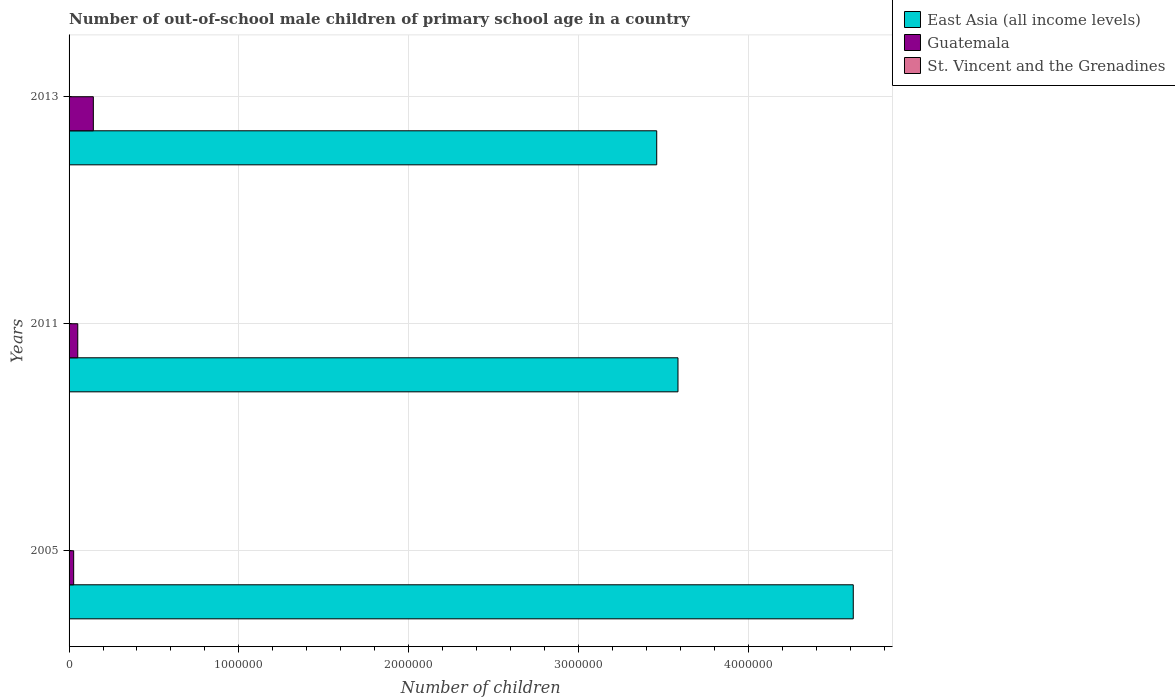How many different coloured bars are there?
Your answer should be compact. 3. Are the number of bars per tick equal to the number of legend labels?
Give a very brief answer. Yes. What is the number of out-of-school male children in East Asia (all income levels) in 2013?
Keep it short and to the point. 3.46e+06. Across all years, what is the maximum number of out-of-school male children in East Asia (all income levels)?
Give a very brief answer. 4.62e+06. Across all years, what is the minimum number of out-of-school male children in Guatemala?
Provide a succinct answer. 2.71e+04. What is the total number of out-of-school male children in East Asia (all income levels) in the graph?
Your response must be concise. 1.17e+07. What is the difference between the number of out-of-school male children in St. Vincent and the Grenadines in 2005 and that in 2011?
Make the answer very short. -191. What is the difference between the number of out-of-school male children in East Asia (all income levels) in 2005 and the number of out-of-school male children in St. Vincent and the Grenadines in 2011?
Keep it short and to the point. 4.62e+06. What is the average number of out-of-school male children in East Asia (all income levels) per year?
Ensure brevity in your answer.  3.89e+06. In the year 2011, what is the difference between the number of out-of-school male children in East Asia (all income levels) and number of out-of-school male children in Guatemala?
Give a very brief answer. 3.54e+06. What is the ratio of the number of out-of-school male children in Guatemala in 2005 to that in 2013?
Ensure brevity in your answer.  0.19. Is the number of out-of-school male children in Guatemala in 2005 less than that in 2013?
Offer a terse response. Yes. Is the difference between the number of out-of-school male children in East Asia (all income levels) in 2011 and 2013 greater than the difference between the number of out-of-school male children in Guatemala in 2011 and 2013?
Give a very brief answer. Yes. What is the difference between the highest and the second highest number of out-of-school male children in East Asia (all income levels)?
Offer a terse response. 1.03e+06. What is the difference between the highest and the lowest number of out-of-school male children in Guatemala?
Make the answer very short. 1.16e+05. In how many years, is the number of out-of-school male children in Guatemala greater than the average number of out-of-school male children in Guatemala taken over all years?
Your answer should be compact. 1. Is the sum of the number of out-of-school male children in St. Vincent and the Grenadines in 2005 and 2011 greater than the maximum number of out-of-school male children in Guatemala across all years?
Ensure brevity in your answer.  No. What does the 3rd bar from the top in 2005 represents?
Ensure brevity in your answer.  East Asia (all income levels). What does the 3rd bar from the bottom in 2005 represents?
Your answer should be very brief. St. Vincent and the Grenadines. Is it the case that in every year, the sum of the number of out-of-school male children in Guatemala and number of out-of-school male children in St. Vincent and the Grenadines is greater than the number of out-of-school male children in East Asia (all income levels)?
Offer a very short reply. No. How many bars are there?
Your answer should be compact. 9. Are all the bars in the graph horizontal?
Your response must be concise. Yes. Are the values on the major ticks of X-axis written in scientific E-notation?
Your response must be concise. No. Does the graph contain grids?
Provide a short and direct response. Yes. How are the legend labels stacked?
Your answer should be compact. Vertical. What is the title of the graph?
Your answer should be compact. Number of out-of-school male children of primary school age in a country. What is the label or title of the X-axis?
Your answer should be very brief. Number of children. What is the label or title of the Y-axis?
Keep it short and to the point. Years. What is the Number of children of East Asia (all income levels) in 2005?
Provide a short and direct response. 4.62e+06. What is the Number of children of Guatemala in 2005?
Offer a very short reply. 2.71e+04. What is the Number of children of St. Vincent and the Grenadines in 2005?
Give a very brief answer. 35. What is the Number of children of East Asia (all income levels) in 2011?
Offer a very short reply. 3.59e+06. What is the Number of children in Guatemala in 2011?
Offer a very short reply. 5.12e+04. What is the Number of children of St. Vincent and the Grenadines in 2011?
Your answer should be compact. 226. What is the Number of children in East Asia (all income levels) in 2013?
Provide a succinct answer. 3.46e+06. What is the Number of children in Guatemala in 2013?
Your answer should be very brief. 1.43e+05. What is the Number of children in St. Vincent and the Grenadines in 2013?
Offer a very short reply. 178. Across all years, what is the maximum Number of children of East Asia (all income levels)?
Make the answer very short. 4.62e+06. Across all years, what is the maximum Number of children of Guatemala?
Offer a very short reply. 1.43e+05. Across all years, what is the maximum Number of children in St. Vincent and the Grenadines?
Provide a short and direct response. 226. Across all years, what is the minimum Number of children of East Asia (all income levels)?
Provide a short and direct response. 3.46e+06. Across all years, what is the minimum Number of children in Guatemala?
Your response must be concise. 2.71e+04. What is the total Number of children in East Asia (all income levels) in the graph?
Ensure brevity in your answer.  1.17e+07. What is the total Number of children of Guatemala in the graph?
Give a very brief answer. 2.21e+05. What is the total Number of children in St. Vincent and the Grenadines in the graph?
Keep it short and to the point. 439. What is the difference between the Number of children in East Asia (all income levels) in 2005 and that in 2011?
Make the answer very short. 1.03e+06. What is the difference between the Number of children of Guatemala in 2005 and that in 2011?
Provide a succinct answer. -2.42e+04. What is the difference between the Number of children in St. Vincent and the Grenadines in 2005 and that in 2011?
Keep it short and to the point. -191. What is the difference between the Number of children of East Asia (all income levels) in 2005 and that in 2013?
Provide a short and direct response. 1.16e+06. What is the difference between the Number of children of Guatemala in 2005 and that in 2013?
Give a very brief answer. -1.16e+05. What is the difference between the Number of children in St. Vincent and the Grenadines in 2005 and that in 2013?
Ensure brevity in your answer.  -143. What is the difference between the Number of children of East Asia (all income levels) in 2011 and that in 2013?
Your response must be concise. 1.25e+05. What is the difference between the Number of children of Guatemala in 2011 and that in 2013?
Your answer should be very brief. -9.17e+04. What is the difference between the Number of children in East Asia (all income levels) in 2005 and the Number of children in Guatemala in 2011?
Offer a very short reply. 4.57e+06. What is the difference between the Number of children of East Asia (all income levels) in 2005 and the Number of children of St. Vincent and the Grenadines in 2011?
Offer a terse response. 4.62e+06. What is the difference between the Number of children of Guatemala in 2005 and the Number of children of St. Vincent and the Grenadines in 2011?
Give a very brief answer. 2.69e+04. What is the difference between the Number of children of East Asia (all income levels) in 2005 and the Number of children of Guatemala in 2013?
Your answer should be very brief. 4.48e+06. What is the difference between the Number of children in East Asia (all income levels) in 2005 and the Number of children in St. Vincent and the Grenadines in 2013?
Your answer should be very brief. 4.62e+06. What is the difference between the Number of children of Guatemala in 2005 and the Number of children of St. Vincent and the Grenadines in 2013?
Keep it short and to the point. 2.69e+04. What is the difference between the Number of children in East Asia (all income levels) in 2011 and the Number of children in Guatemala in 2013?
Make the answer very short. 3.44e+06. What is the difference between the Number of children of East Asia (all income levels) in 2011 and the Number of children of St. Vincent and the Grenadines in 2013?
Offer a very short reply. 3.59e+06. What is the difference between the Number of children in Guatemala in 2011 and the Number of children in St. Vincent and the Grenadines in 2013?
Provide a succinct answer. 5.11e+04. What is the average Number of children of East Asia (all income levels) per year?
Give a very brief answer. 3.89e+06. What is the average Number of children in Guatemala per year?
Offer a very short reply. 7.37e+04. What is the average Number of children in St. Vincent and the Grenadines per year?
Offer a terse response. 146.33. In the year 2005, what is the difference between the Number of children of East Asia (all income levels) and Number of children of Guatemala?
Your answer should be very brief. 4.59e+06. In the year 2005, what is the difference between the Number of children of East Asia (all income levels) and Number of children of St. Vincent and the Grenadines?
Ensure brevity in your answer.  4.62e+06. In the year 2005, what is the difference between the Number of children of Guatemala and Number of children of St. Vincent and the Grenadines?
Offer a very short reply. 2.70e+04. In the year 2011, what is the difference between the Number of children in East Asia (all income levels) and Number of children in Guatemala?
Ensure brevity in your answer.  3.54e+06. In the year 2011, what is the difference between the Number of children of East Asia (all income levels) and Number of children of St. Vincent and the Grenadines?
Offer a terse response. 3.59e+06. In the year 2011, what is the difference between the Number of children of Guatemala and Number of children of St. Vincent and the Grenadines?
Offer a terse response. 5.10e+04. In the year 2013, what is the difference between the Number of children of East Asia (all income levels) and Number of children of Guatemala?
Ensure brevity in your answer.  3.32e+06. In the year 2013, what is the difference between the Number of children of East Asia (all income levels) and Number of children of St. Vincent and the Grenadines?
Ensure brevity in your answer.  3.46e+06. In the year 2013, what is the difference between the Number of children in Guatemala and Number of children in St. Vincent and the Grenadines?
Your answer should be very brief. 1.43e+05. What is the ratio of the Number of children of East Asia (all income levels) in 2005 to that in 2011?
Give a very brief answer. 1.29. What is the ratio of the Number of children of Guatemala in 2005 to that in 2011?
Keep it short and to the point. 0.53. What is the ratio of the Number of children of St. Vincent and the Grenadines in 2005 to that in 2011?
Give a very brief answer. 0.15. What is the ratio of the Number of children of East Asia (all income levels) in 2005 to that in 2013?
Ensure brevity in your answer.  1.33. What is the ratio of the Number of children of Guatemala in 2005 to that in 2013?
Offer a very short reply. 0.19. What is the ratio of the Number of children in St. Vincent and the Grenadines in 2005 to that in 2013?
Your response must be concise. 0.2. What is the ratio of the Number of children in East Asia (all income levels) in 2011 to that in 2013?
Provide a succinct answer. 1.04. What is the ratio of the Number of children of Guatemala in 2011 to that in 2013?
Provide a short and direct response. 0.36. What is the ratio of the Number of children of St. Vincent and the Grenadines in 2011 to that in 2013?
Your answer should be very brief. 1.27. What is the difference between the highest and the second highest Number of children in East Asia (all income levels)?
Offer a very short reply. 1.03e+06. What is the difference between the highest and the second highest Number of children in Guatemala?
Give a very brief answer. 9.17e+04. What is the difference between the highest and the second highest Number of children of St. Vincent and the Grenadines?
Make the answer very short. 48. What is the difference between the highest and the lowest Number of children of East Asia (all income levels)?
Keep it short and to the point. 1.16e+06. What is the difference between the highest and the lowest Number of children in Guatemala?
Ensure brevity in your answer.  1.16e+05. What is the difference between the highest and the lowest Number of children in St. Vincent and the Grenadines?
Your answer should be compact. 191. 